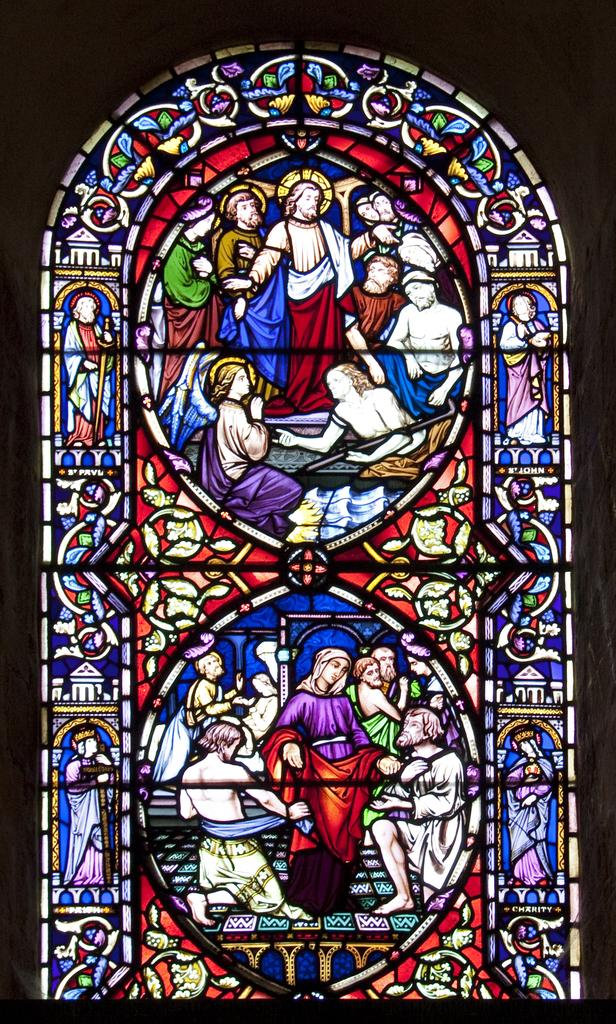What can be seen in the image that provides a view or access to the outdoors? There is a window in the image. What is unique about the window in the image? The window has stained glass attached to it. What company is mentioned in the image? There is no mention of a company in the image. --- Facts: 1. There is a person in the image. 2. The person is wearing a hat. 3. The person is holding a book. Absurd Topics: bicycle, parrot, bookcase Conversation: Who or what can be seen in the image? There is a person in the image. What is the person wearing in the image? The person is wearing a hat. What is the person holding in the image? The person is holding a book. Reasoning: Let's think step by step in order to produce the conversation. We start by identifying the main subject in the image, which is the person. Then, we describe specific features of the person, such as the hat. Next, we observe the actions of the person, noting that they are holding a book. Finally, we ensure that the language is simple and clear. Absurd Question/Answer: What type of bicycle can be seen in the image? There is no bicycle present in the image. --- Facts: 1. There is a cat in the image. 2. The cat is sitting on a chair. 3. The chair is located near a table. Absurd Topics: dog, aquarium Conversation: What type of animal can be seen in the image? There is a cat in the image. What is the cat doing in the image? The cat is sitting on a chair. Where is the chair located in relation to the table in the image? The chair is located near a table. Reasoning: Let's think step by step in order to produce the conversation. We start by identifying the main subject in the image, which is the cat. Then, we describe the specific action of the cat, noting that it is sitting on a chair. Next, we observe the location of the chair in relation to the table in the image. Finally, we ensure that the language is simple and clear. Absurd Question/Answer: What type of aquarium can be seen in the image? There is no aquarium present in the image. --- Facts: 1. There is a group of people in the image. 2. The group of people is standing in front of a building. 3. The building is a school. Absurd Topics: company, feet, story Conversation: How many people can be seen in the image? There is a group of people in the image. What are the people in the image doing? The people in the image are standing in front of a building. 